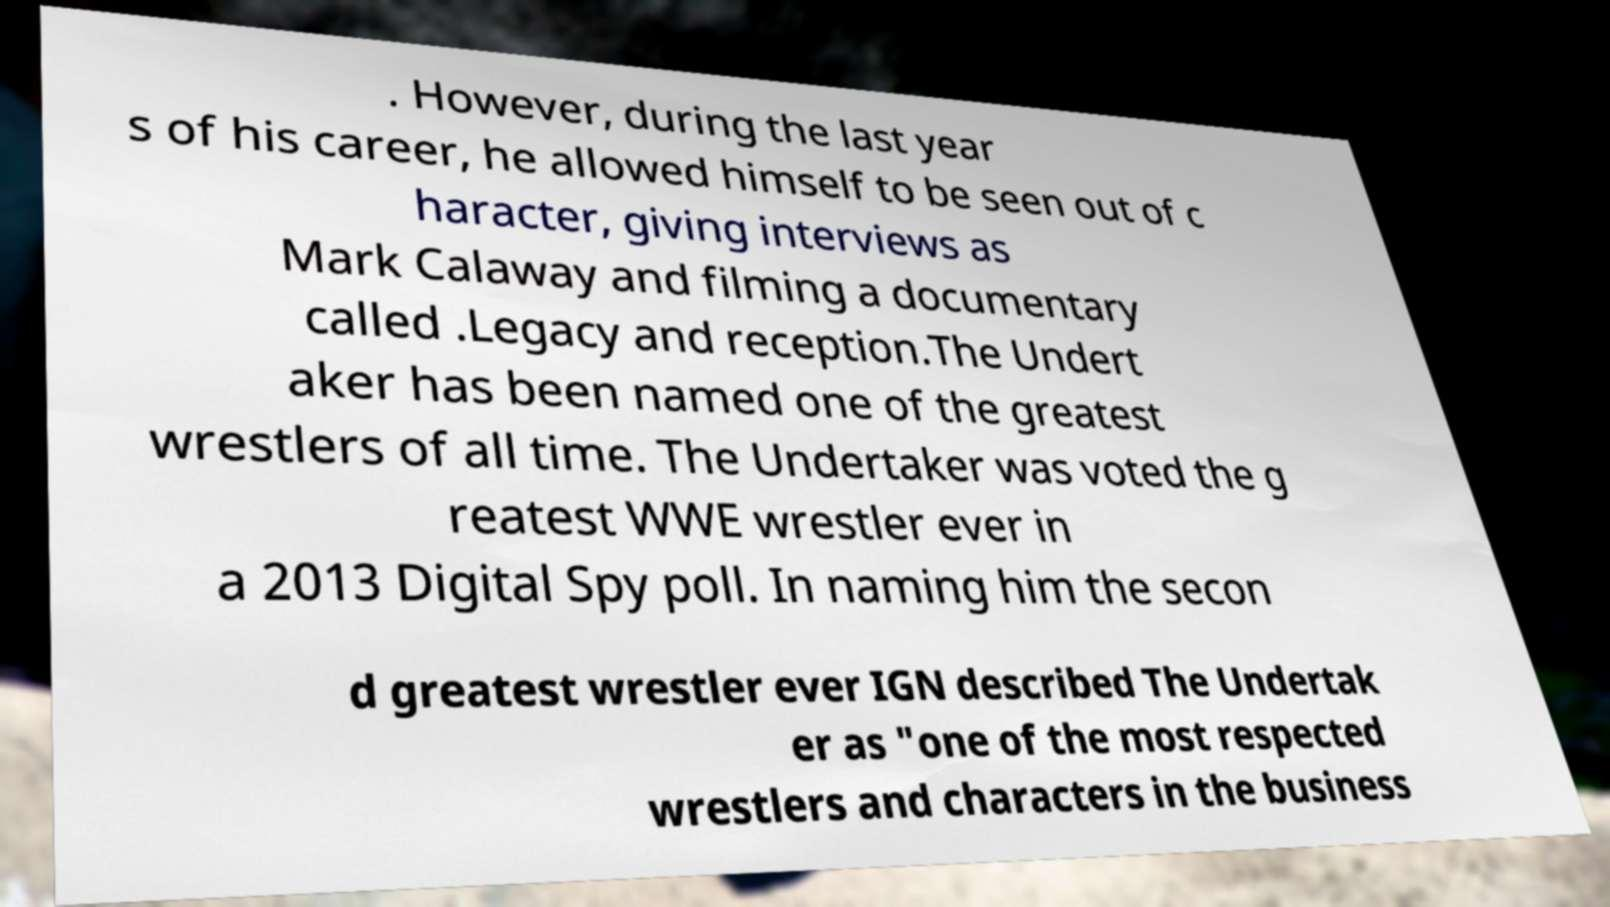What messages or text are displayed in this image? I need them in a readable, typed format. . However, during the last year s of his career, he allowed himself to be seen out of c haracter, giving interviews as Mark Calaway and filming a documentary called .Legacy and reception.The Undert aker has been named one of the greatest wrestlers of all time. The Undertaker was voted the g reatest WWE wrestler ever in a 2013 Digital Spy poll. In naming him the secon d greatest wrestler ever IGN described The Undertak er as "one of the most respected wrestlers and characters in the business 